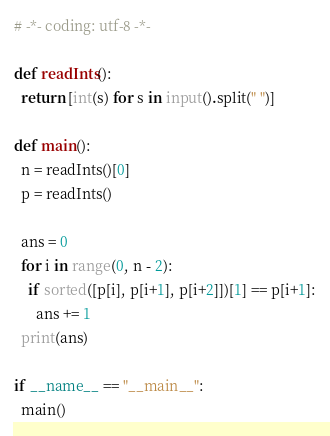Convert code to text. <code><loc_0><loc_0><loc_500><loc_500><_Python_># -*- coding: utf-8 -*-

def readInts():
  return [int(s) for s in input().split(" ")]

def main():
  n = readInts()[0]
  p = readInts()

  ans = 0
  for i in range(0, n - 2):
    if sorted([p[i], p[i+1], p[i+2]])[1] == p[i+1]:
      ans += 1
  print(ans)

if __name__ == "__main__":
  main()
</code> 